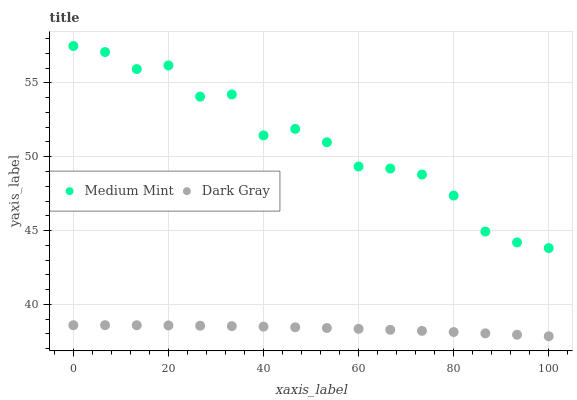Does Dark Gray have the minimum area under the curve?
Answer yes or no. Yes. Does Medium Mint have the maximum area under the curve?
Answer yes or no. Yes. Does Dark Gray have the maximum area under the curve?
Answer yes or no. No. Is Dark Gray the smoothest?
Answer yes or no. Yes. Is Medium Mint the roughest?
Answer yes or no. Yes. Is Dark Gray the roughest?
Answer yes or no. No. Does Dark Gray have the lowest value?
Answer yes or no. Yes. Does Medium Mint have the highest value?
Answer yes or no. Yes. Does Dark Gray have the highest value?
Answer yes or no. No. Is Dark Gray less than Medium Mint?
Answer yes or no. Yes. Is Medium Mint greater than Dark Gray?
Answer yes or no. Yes. Does Dark Gray intersect Medium Mint?
Answer yes or no. No. 